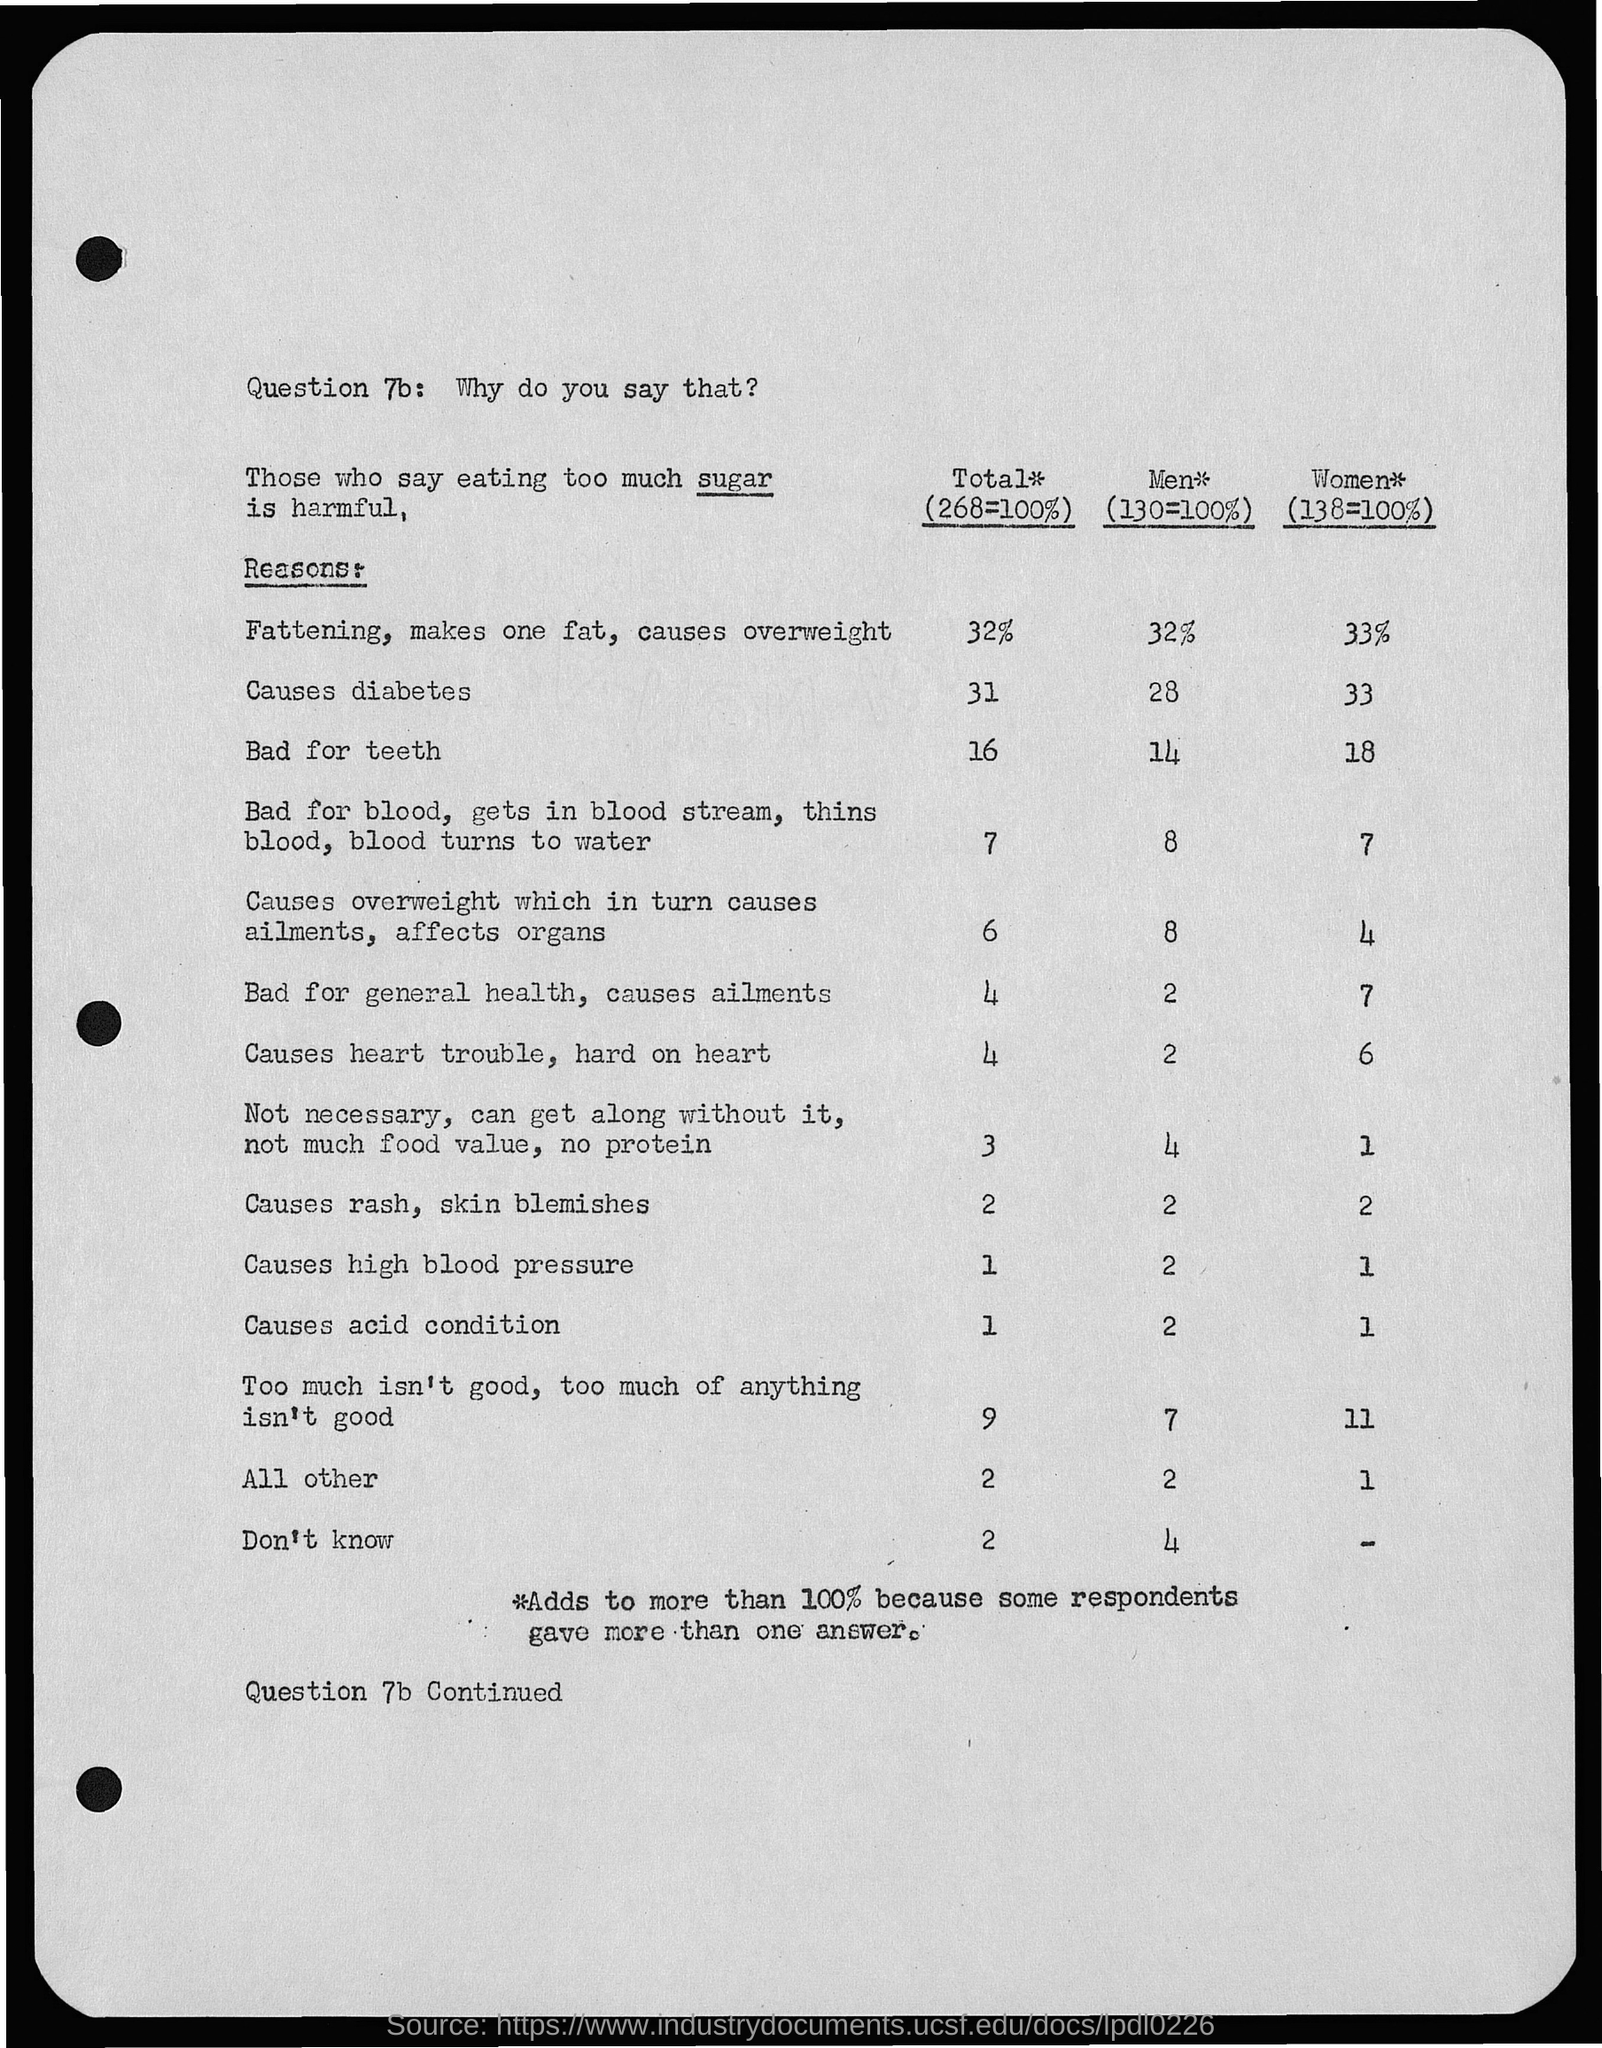Give some essential details in this illustration. What is Question 7b? Why do you say that? 